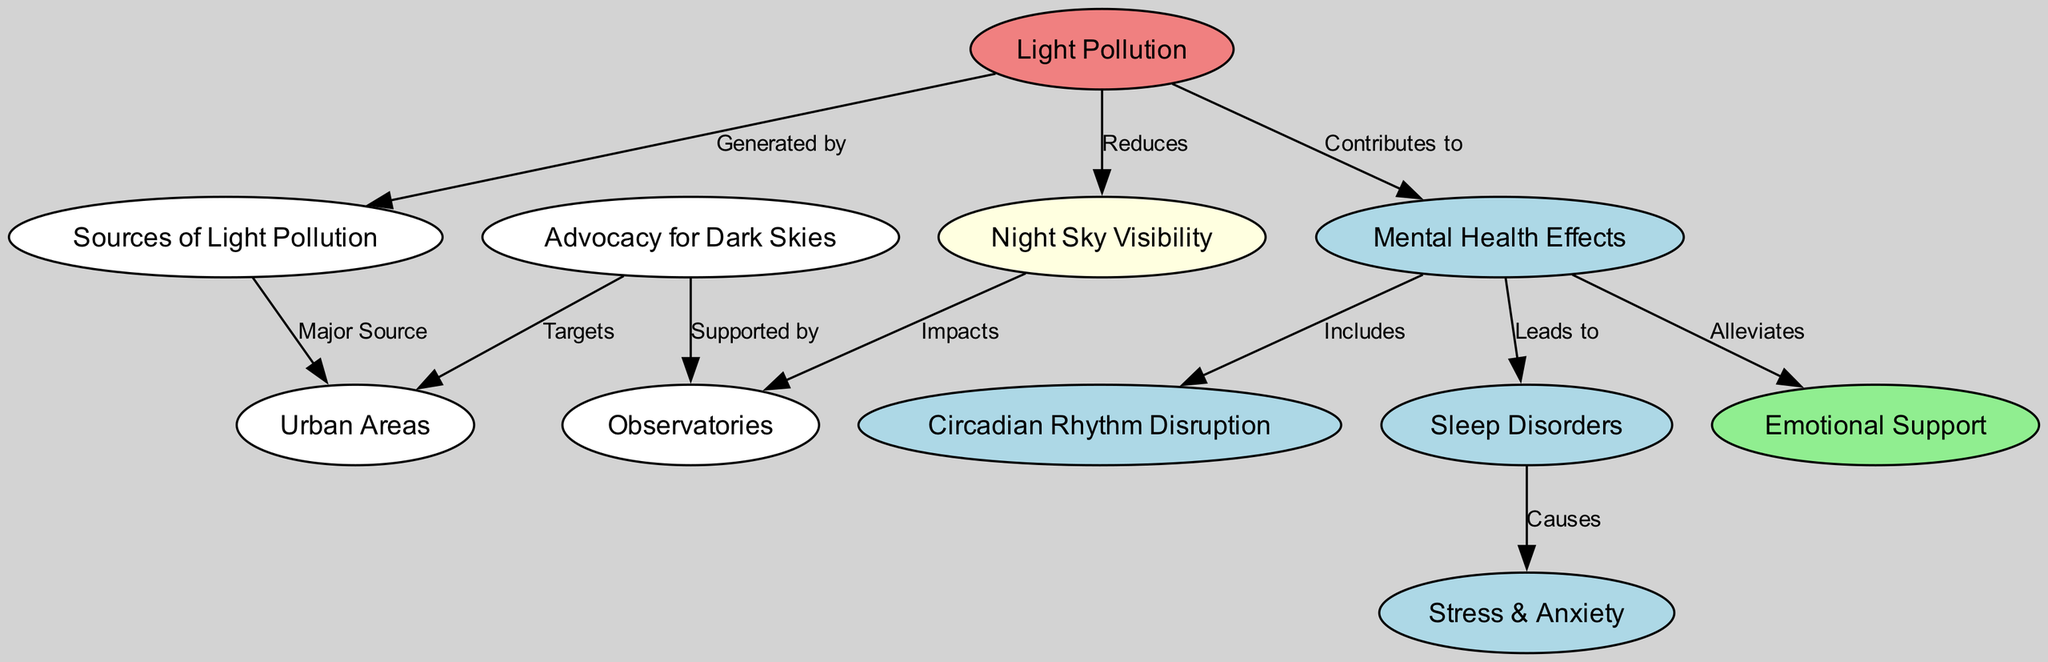What is the main source of light pollution? The diagram indicates that "Urban Areas" is labeled as a major source of "Light Pollution." This relationship is established by the edge labeled "Major Source" connecting "Sources of Light Pollution" to "Urban Areas."
Answer: Urban Areas How does light pollution affect night sky visibility? The diagram shows an edge labeled "Reduces" that connects "Light Pollution" to "Night Sky Visibility," indicating that light pollution has a detrimental effect on the visibility of the night sky.
Answer: Reduces What factor contributes to mental health effects from light pollution? The edge labeled "Contributes to" outlines that "Light Pollution" leads to "Mental Health Effects." Therefore, light pollution has identifiable contributions to mental health concerns.
Answer: Contributes to Which specific mental health effect is included in the diagram? The diagram indicates that "Circadian Rhythm Disruption" is a part of "Mental Health Effects," shown by the edge labeled "Includes." This connection establishes that circadian rhythm disruption is a specific mental health effect associated with light pollution.
Answer: Circadian Rhythm Disruption What is the relationship between sleep disorders and stress & anxiety? According to the diagram, "Sleep Disorders" is connected to "Stress & Anxiety" by an edge labeled "Causes." This means that sleep disorders lead to increased levels of stress and anxiety in individuals.
Answer: Causes How many nodes represent mental health effects in the diagram? The diagram includes four nodes representing different aspects of mental health effects: "Mental Health Effects," "Circadian Rhythm Disruption," "Sleep Disorders," and "Stress & Anxiety." By counting these nodes, we can ascertain that there are four distinct aspects of mental health illustrated in the diagram.
Answer: Four What role do observatories have concerning night sky visibility? The edge labeled "Impacts" indicates that "Night Sky Visibility" directly affects "Observatories." Therefore, there is a significant relationship where night sky visibility is essential for observatories.
Answer: Impacts What type of advocacy targets urban areas? The diagram suggests that "Advocacy for Dark Skies" targets "Urban Areas," as seen in the edge labeled "Targets." This connection illustrates that advocacy efforts are focused on reducing light pollution in urban settings.
Answer: Targets How do emotional support and mental health effects relate? The relationship is shown in the diagram by the edge labeled "Alleviates," indicating that "Emotional Support" plays a role in alleviating the "Mental Health Effects." This highlights the positive influence of emotional support on mental health concerns stemming from light pollution.
Answer: Alleviates 